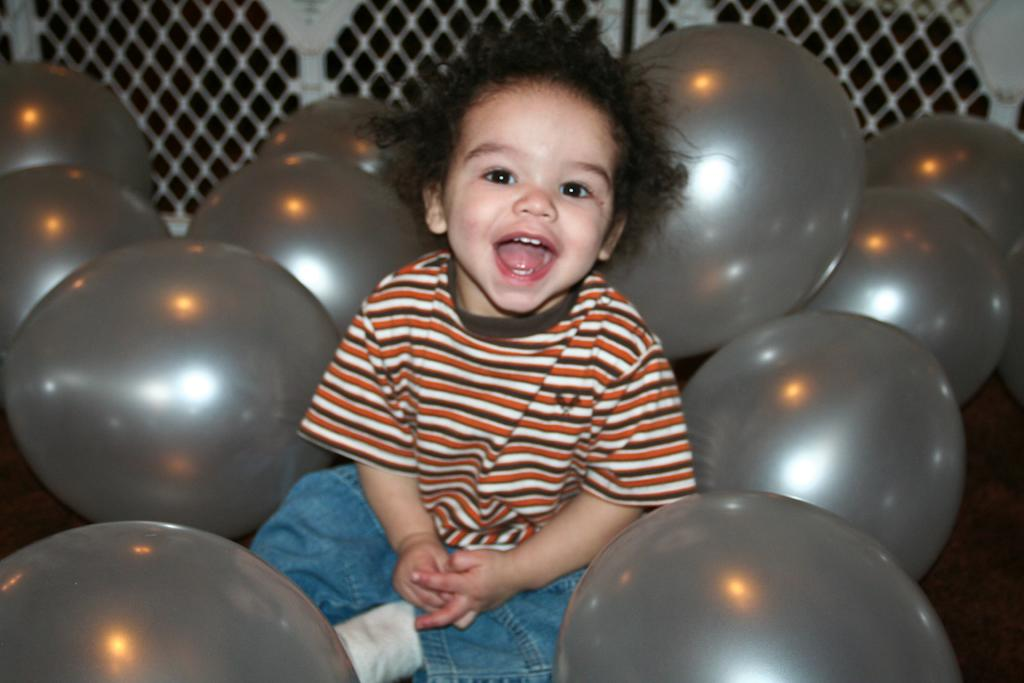What is the main subject of the image? The main subject of the image is a boy. What is the boy wearing on his upper body? The boy is wearing a t-shirt. What is the boy wearing on his lower body? The boy is wearing shorts. What type of footwear is the boy wearing? The boy is wearing socks. What can be seen near the boy in the image? The boy is sitting near grey color balloons. What is visible at the top of the image? There is fencing visible at the top of the image. What type of scarf is the boy wearing in the image? The boy is not wearing a scarf in the image. What type of lace is visible on the boy's clothing in the image? There is no lace visible on the boy's clothing in the image. 